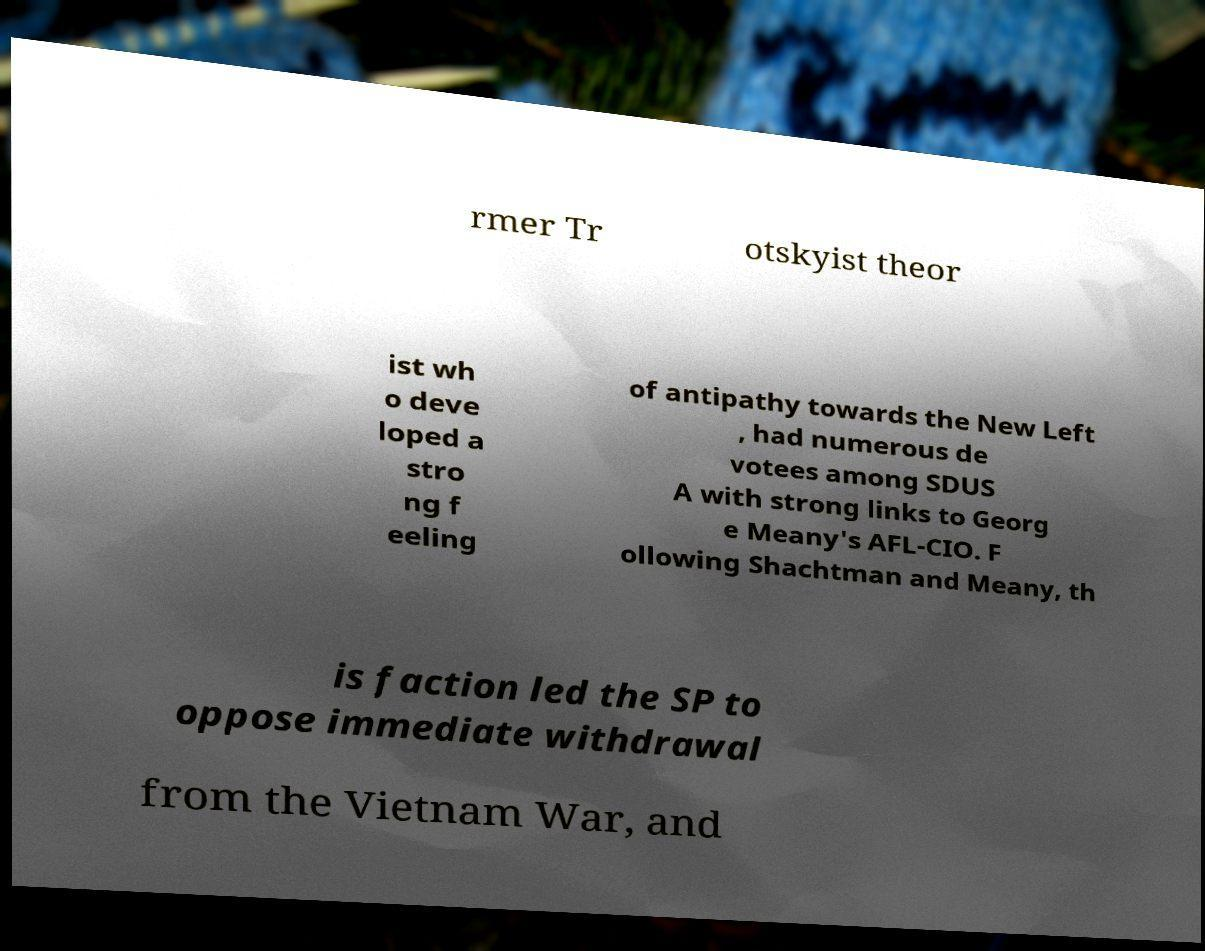What messages or text are displayed in this image? I need them in a readable, typed format. rmer Tr otskyist theor ist wh o deve loped a stro ng f eeling of antipathy towards the New Left , had numerous de votees among SDUS A with strong links to Georg e Meany's AFL-CIO. F ollowing Shachtman and Meany, th is faction led the SP to oppose immediate withdrawal from the Vietnam War, and 